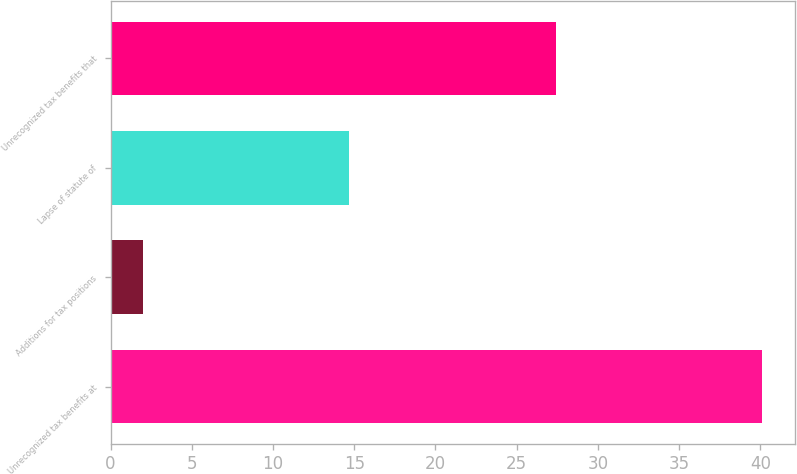<chart> <loc_0><loc_0><loc_500><loc_500><bar_chart><fcel>Unrecognized tax benefits at<fcel>Additions for tax positions<fcel>Lapse of statute of<fcel>Unrecognized tax benefits that<nl><fcel>40.1<fcel>2<fcel>14.7<fcel>27.4<nl></chart> 